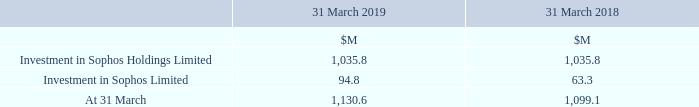3 Investments
The investment in Sophos Holdings Limited, a holding company for the Sophos Group, comprises 100% of the ordinary share capital.
The investment in Sophos Limited comprises share-based payment expenses for equity awards granted to participants employed by Sophos Limited and its subsidiaries.
What does the investment in Sophos Holdings Limited comprise? 100% of the ordinary share capital. What does the investment in Sophos Limited comprise? Share-based payment expenses for equity awards granted to participants employed by sophos limited and its subsidiaries. What are the different investments listed in the table? Investment in sophos holdings limited, investment in sophos limited. In which year was the amount at the end of the fiscal year larger? 1,130.6>1,099.1
Answer: 2019. What was the change in the amount of Investment in Sophos Limited in 2019 from 2018?
Answer scale should be: million. 94.8-63.3
Answer: 31.5. What was the percentage change in the amount of Investment in Sophos Limited in 2019 from 2018?
Answer scale should be: percent. (94.8-63.3)/63.3
Answer: 49.76. 